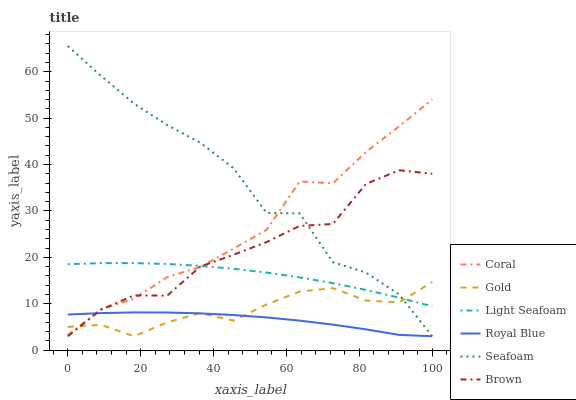Does Royal Blue have the minimum area under the curve?
Answer yes or no. Yes. Does Seafoam have the maximum area under the curve?
Answer yes or no. Yes. Does Gold have the minimum area under the curve?
Answer yes or no. No. Does Gold have the maximum area under the curve?
Answer yes or no. No. Is Light Seafoam the smoothest?
Answer yes or no. Yes. Is Seafoam the roughest?
Answer yes or no. Yes. Is Gold the smoothest?
Answer yes or no. No. Is Gold the roughest?
Answer yes or no. No. Does Coral have the lowest value?
Answer yes or no. No. Does Seafoam have the highest value?
Answer yes or no. Yes. Does Gold have the highest value?
Answer yes or no. No. Is Royal Blue less than Light Seafoam?
Answer yes or no. Yes. Is Light Seafoam greater than Royal Blue?
Answer yes or no. Yes. Does Royal Blue intersect Seafoam?
Answer yes or no. Yes. Is Royal Blue less than Seafoam?
Answer yes or no. No. Is Royal Blue greater than Seafoam?
Answer yes or no. No. Does Royal Blue intersect Light Seafoam?
Answer yes or no. No. 